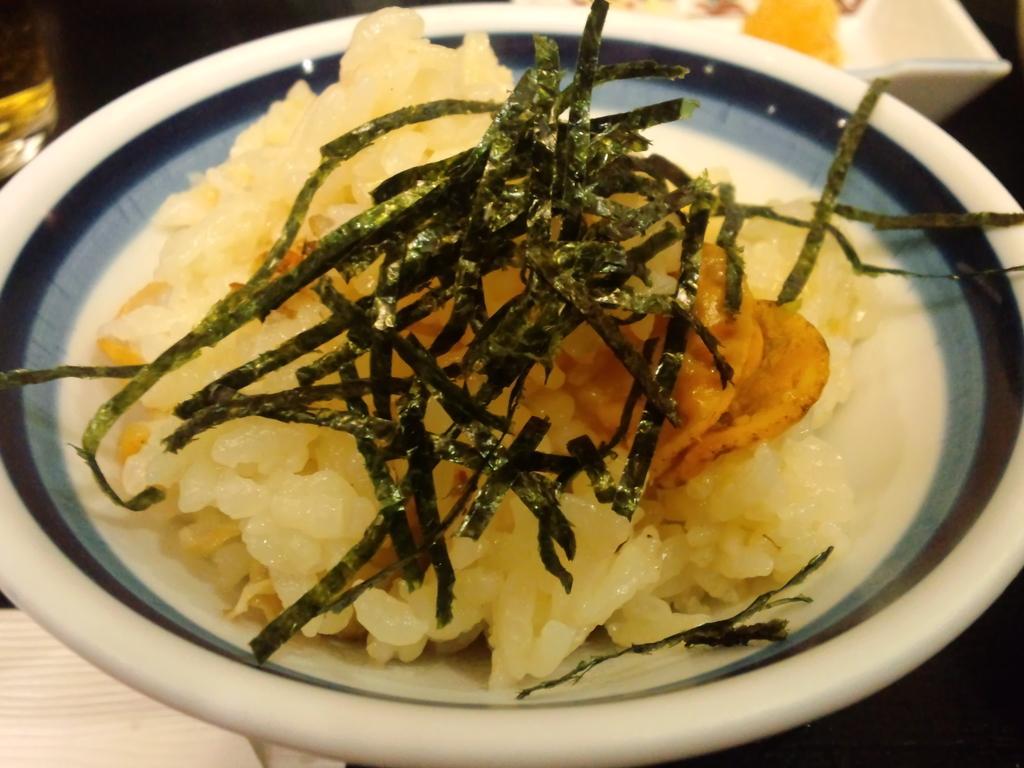In one or two sentences, can you explain what this image depicts? In the image we can see a table, on the table there is a plate, in the plate there is food. Behind the plate there is glass. 